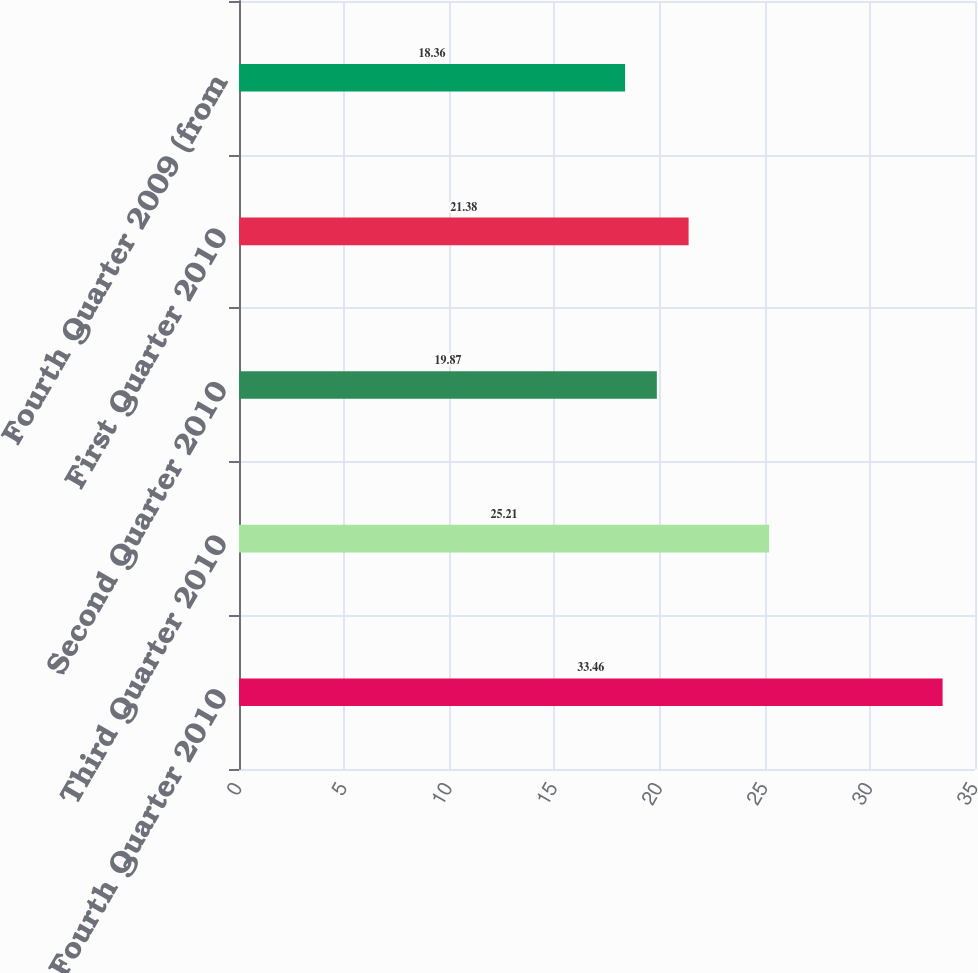Convert chart. <chart><loc_0><loc_0><loc_500><loc_500><bar_chart><fcel>Fourth Quarter 2010<fcel>Third Quarter 2010<fcel>Second Quarter 2010<fcel>First Quarter 2010<fcel>Fourth Quarter 2009 (from<nl><fcel>33.46<fcel>25.21<fcel>19.87<fcel>21.38<fcel>18.36<nl></chart> 